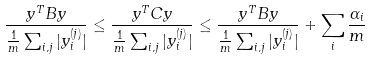Convert formula to latex. <formula><loc_0><loc_0><loc_500><loc_500>\frac { y ^ { T } B y } { \frac { 1 } { m } \sum _ { i , j } | y _ { i } ^ { ( j ) } | } \leq \frac { y ^ { T } C y } { \frac { 1 } { m } \sum _ { i , j } | y _ { i } ^ { ( j ) } | } \leq \frac { y ^ { T } B y } { \frac { 1 } { m } \sum _ { i , j } | y _ { i } ^ { ( j ) } | } + \sum _ { i } \frac { \alpha _ { i } } { m }</formula> 